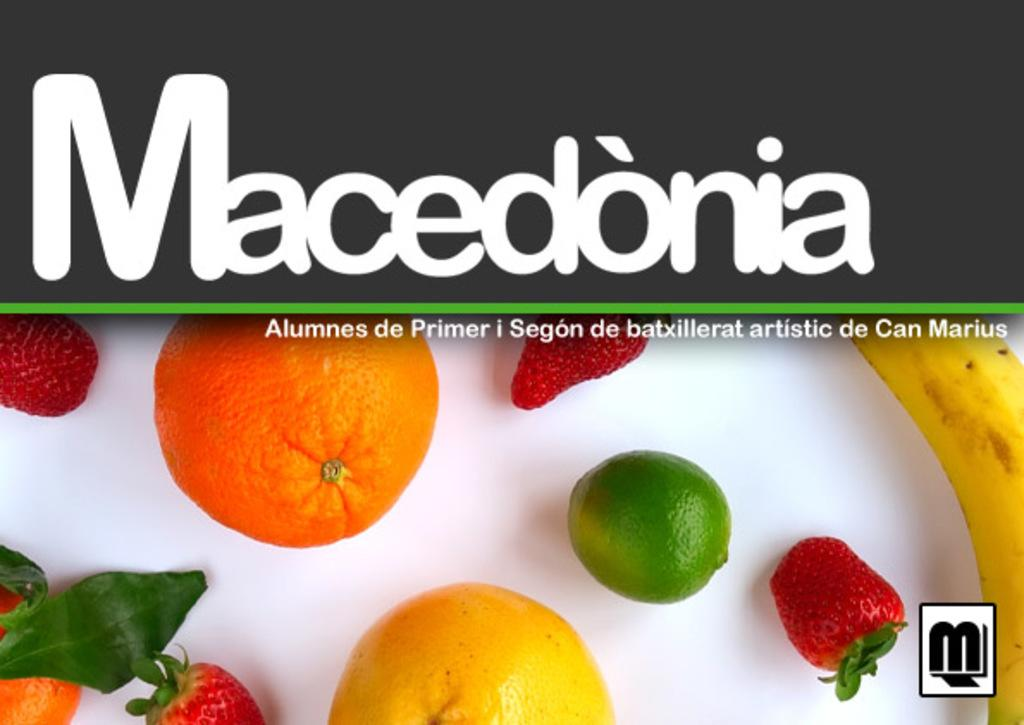What is present in the image that features multiple fruits? There is a poster in the image that contains many fruits. Can you describe the poster in more detail? The poster contains a variety of fruits, but no other elements are mentioned in the provided facts. What type of metal is used to create the argument on the poster? There is no mention of metal or an argument on the poster in the provided facts. The poster only contains many fruits. 